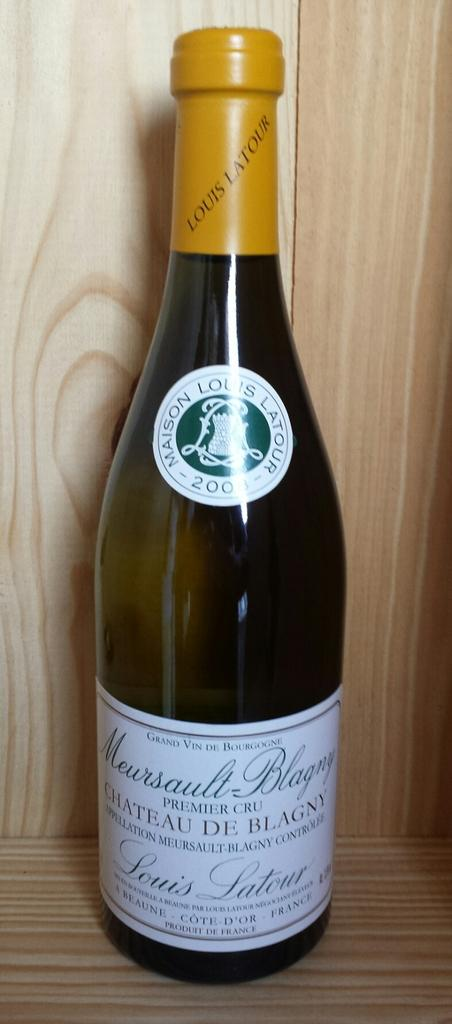<image>
Relay a brief, clear account of the picture shown. A bottle of wine against a wooden background from France called Meaursalt-Blagny. 